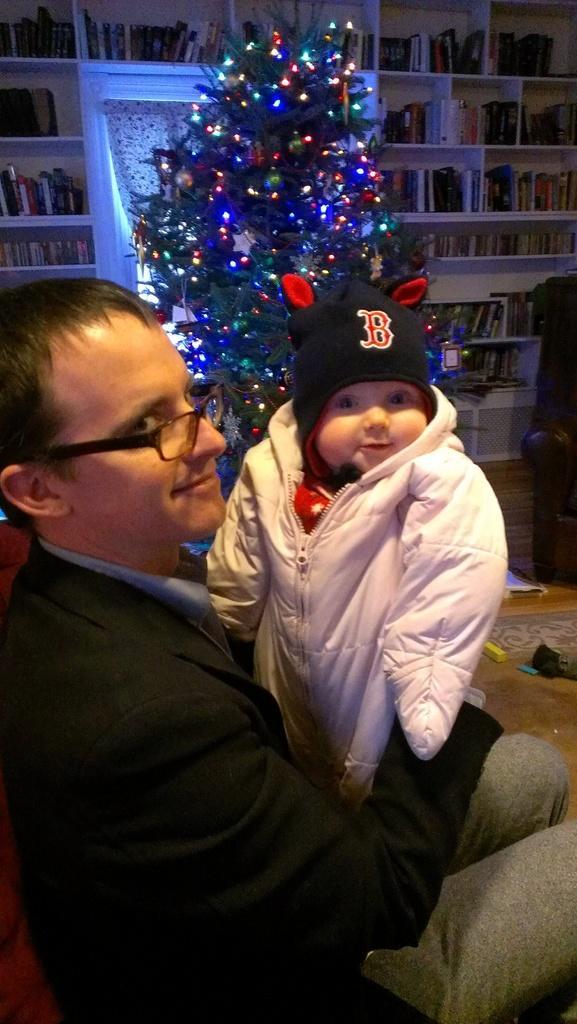Describe this image in one or two sentences. In this image, at the left side there is a man standing, he is wearing specs, we can see a small kid beside the man, in the background there is an x-mass tree, we can see some shelves, there are some books kept in the shelves. 